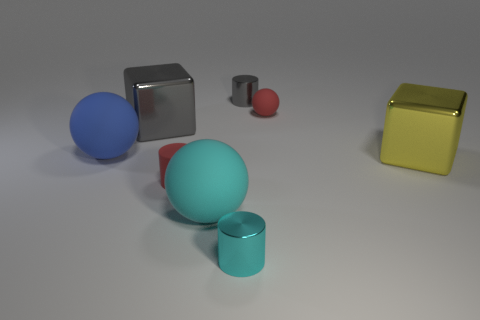What number of other objects are there of the same material as the cyan cylinder? 3 